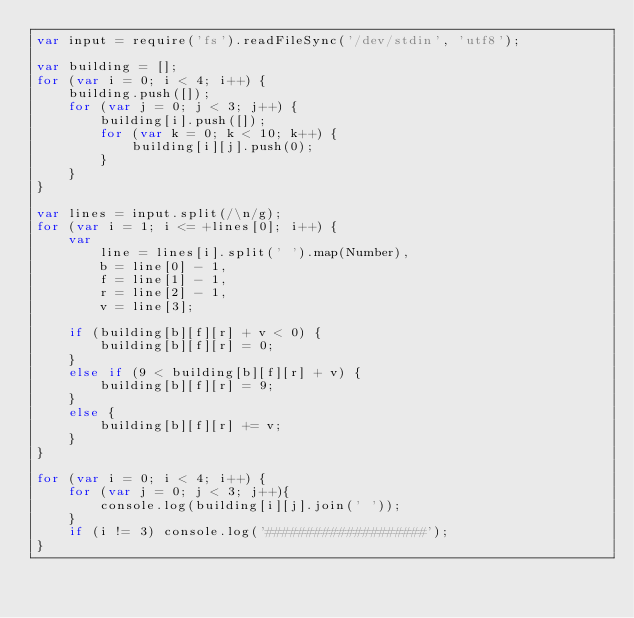<code> <loc_0><loc_0><loc_500><loc_500><_JavaScript_>var input = require('fs').readFileSync('/dev/stdin', 'utf8');

var building = [];
for (var i = 0; i < 4; i++) {
    building.push([]);
    for (var j = 0; j < 3; j++) {
        building[i].push([]);
        for (var k = 0; k < 10; k++) {
            building[i][j].push(0);
        }
    }
}

var lines = input.split(/\n/g);
for (var i = 1; i <= +lines[0]; i++) {
    var
        line = lines[i].split(' ').map(Number),
        b = line[0] - 1,
        f = line[1] - 1,
        r = line[2] - 1,
        v = line[3];

    if (building[b][f][r] + v < 0) {
        building[b][f][r] = 0;
    }
    else if (9 < building[b][f][r] + v) {
        building[b][f][r] = 9;
    }
    else {
        building[b][f][r] += v;
    }
}

for (var i = 0; i < 4; i++) {
    for (var j = 0; j < 3; j++){ 
        console.log(building[i][j].join(' '));
    }
    if (i != 3) console.log('####################');
}</code> 